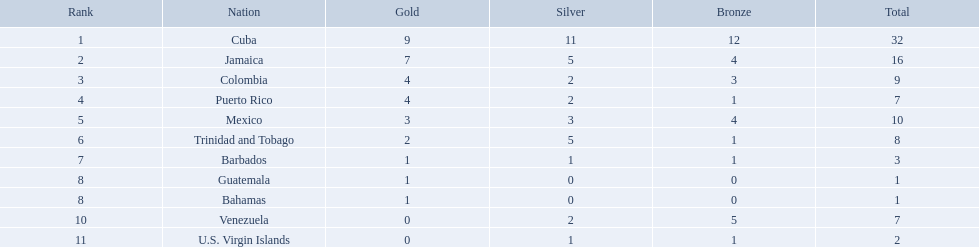What teams had four gold medals? Colombia, Puerto Rico. Of these two, which team only had one bronze medal? Puerto Rico. Which 3 countries were awarded the most medals? Cuba, Jamaica, Colombia. Of these 3 countries which ones are islands? Cuba, Jamaica. Which one won the most silver medals? Cuba. Which nations played in the games? Cuba, Jamaica, Colombia, Puerto Rico, Mexico, Trinidad and Tobago, Barbados, Guatemala, Bahamas, Venezuela, U.S. Virgin Islands. How many silver medals did they win? 11, 5, 2, 2, 3, 5, 1, 0, 0, 2, 1. Which team won the most silver? Cuba. Which groups hold exactly 4 gold medals? Colombia, Puerto Rico. Of those groups, which has specifically 1 bronze medal? Puerto Rico. Which 3 countries earned the most medals? Cuba, Jamaica, Colombia. Among these 3 countries, which ones are islands? Cuba, Jamaica. Which one secured the most silver medals? Cuba. Help me parse the entirety of this table. {'header': ['Rank', 'Nation', 'Gold', 'Silver', 'Bronze', 'Total'], 'rows': [['1', 'Cuba', '9', '11', '12', '32'], ['2', 'Jamaica', '7', '5', '4', '16'], ['3', 'Colombia', '4', '2', '3', '9'], ['4', 'Puerto Rico', '4', '2', '1', '7'], ['5', 'Mexico', '3', '3', '4', '10'], ['6', 'Trinidad and Tobago', '2', '5', '1', '8'], ['7', 'Barbados', '1', '1', '1', '3'], ['8', 'Guatemala', '1', '0', '0', '1'], ['8', 'Bahamas', '1', '0', '0', '1'], ['10', 'Venezuela', '0', '2', '5', '7'], ['11', 'U.S. Virgin Islands', '0', '1', '1', '2']]} Which countries participated in the competitions? Cuba, Jamaica, Colombia, Puerto Rico, Mexico, Trinidad and Tobago, Barbados, Guatemala, Bahamas, Venezuela, U.S. Virgin Islands. How many silver medals did they achieve? 11, 5, 2, 2, 3, 5, 1, 0, 0, 2, 1. Which squad secured the most silver? Cuba. Which 3 countries won the most medals? Cuba, Jamaica, Colombia. From these 3 countries, which ones are islands? Cuba, Jamaica. Which one got the most silver medals? Cuba. Which teams possess precisely 4 gold medals? Colombia, Puerto Rico. Among those teams, which one has exactly 1 bronze medal? Puerto Rico. Which country has secured a minimum of 4 gold medals? Cuba, Jamaica, Colombia, Puerto Rico. Among these nations, who has the lowest number of bronze medals? Puerto Rico. Which country has secured a minimum of 4 gold medals? Cuba, Jamaica, Colombia, Puerto Rico. Among these nations, who holds the lowest number of bronze medals? Puerto Rico. Which three countries earned the most medals overall? Cuba, Jamaica, Colombia. From these, which are island nations? Cuba, Jamaica. Which one of them won the greatest number of silver medals? Cuba. Which countries competed in the games? Cuba, Jamaica, Colombia, Puerto Rico, Mexico, Trinidad and Tobago, Barbados, Guatemala, Bahamas, Venezuela, U.S. Virgin Islands. What was the total number of silver medals they won? 11, 5, 2, 2, 3, 5, 1, 0, 0, 2, 1. Which team secured the most silver medals? Cuba. 